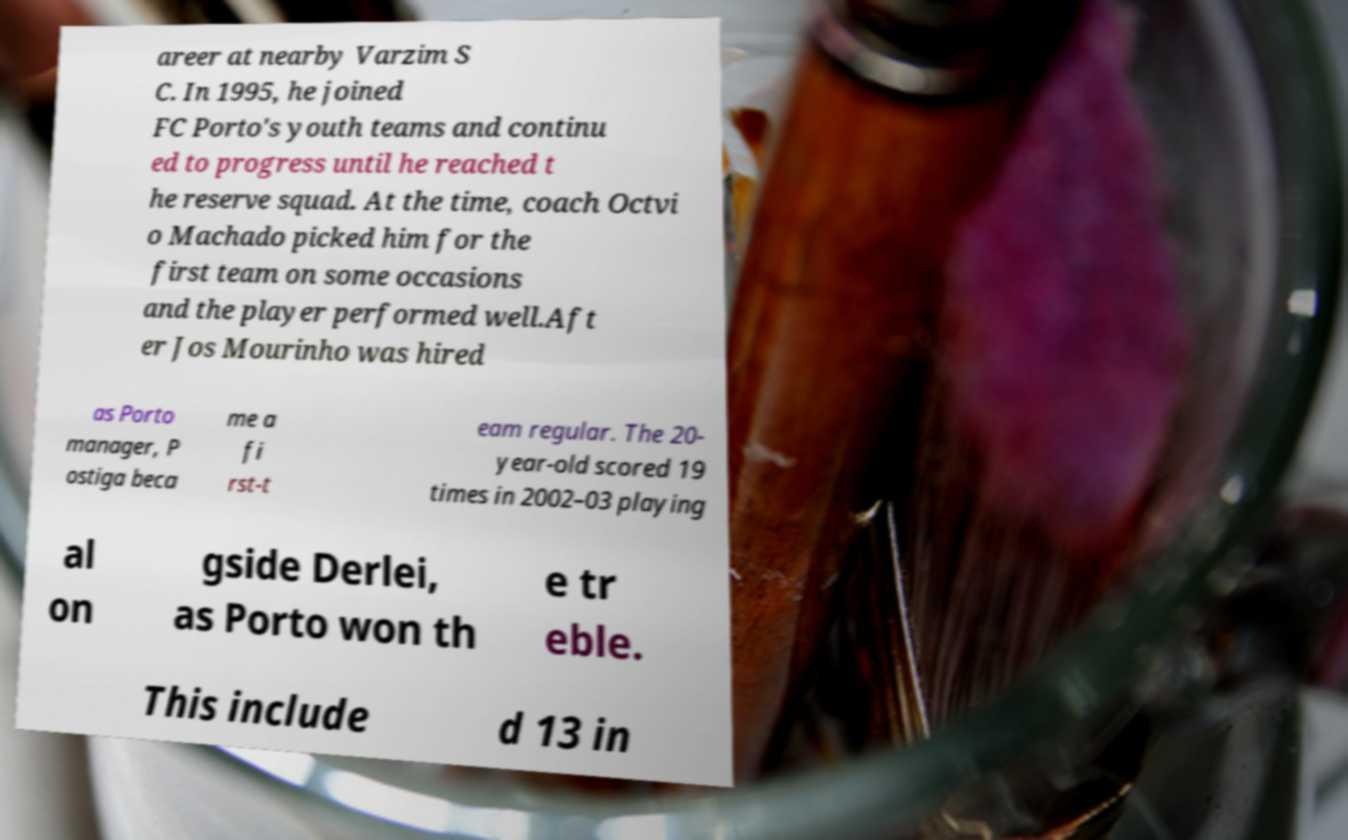Can you read and provide the text displayed in the image?This photo seems to have some interesting text. Can you extract and type it out for me? areer at nearby Varzim S C. In 1995, he joined FC Porto's youth teams and continu ed to progress until he reached t he reserve squad. At the time, coach Octvi o Machado picked him for the first team on some occasions and the player performed well.Aft er Jos Mourinho was hired as Porto manager, P ostiga beca me a fi rst-t eam regular. The 20- year-old scored 19 times in 2002–03 playing al on gside Derlei, as Porto won th e tr eble. This include d 13 in 